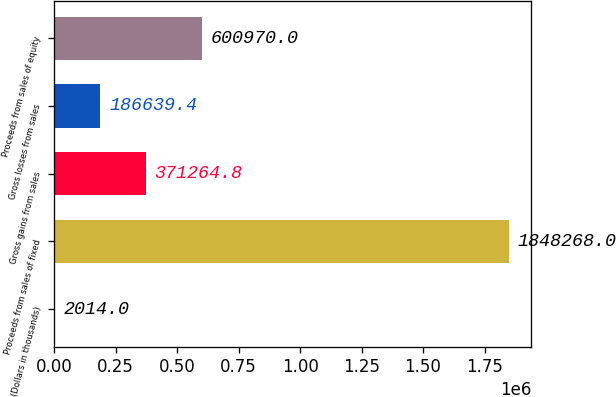<chart> <loc_0><loc_0><loc_500><loc_500><bar_chart><fcel>(Dollars in thousands)<fcel>Proceeds from sales of fixed<fcel>Gross gains from sales<fcel>Gross losses from sales<fcel>Proceeds from sales of equity<nl><fcel>2014<fcel>1.84827e+06<fcel>371265<fcel>186639<fcel>600970<nl></chart> 